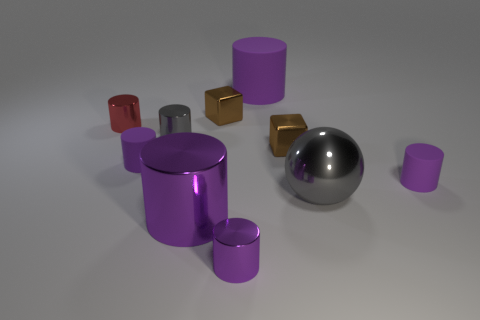There is another big cylinder that is the same color as the large shiny cylinder; what material is it?
Make the answer very short. Rubber. What is the material of the gray object that is the same size as the red shiny object?
Keep it short and to the point. Metal. Is the small red object made of the same material as the tiny gray object?
Your response must be concise. Yes. The thing that is both behind the small red object and on the left side of the large matte thing is what color?
Offer a terse response. Brown. Do the tiny metallic block that is in front of the small red object and the ball have the same color?
Your response must be concise. No. What shape is the purple metal object that is the same size as the red cylinder?
Your answer should be very brief. Cylinder. How many other things are the same color as the large metal sphere?
Provide a succinct answer. 1. What number of other things are there of the same material as the small gray thing
Ensure brevity in your answer.  6. There is a gray sphere; does it have the same size as the metal cube that is in front of the small red object?
Provide a succinct answer. No. What color is the sphere?
Give a very brief answer. Gray. 